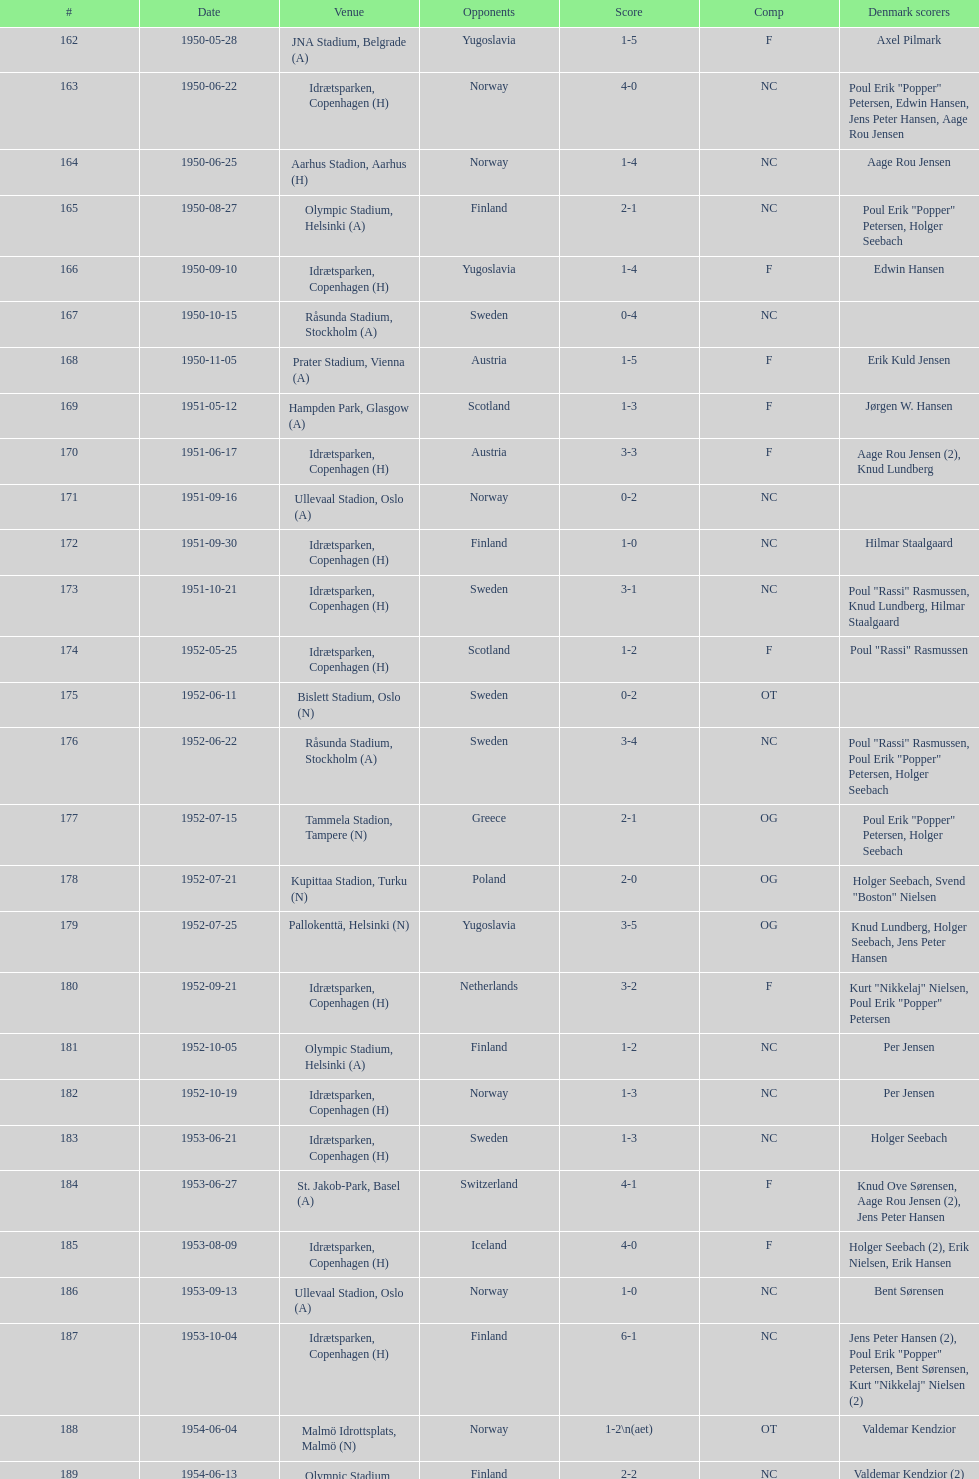When did the team last experience a 0-6 record? 1959-06-21. 